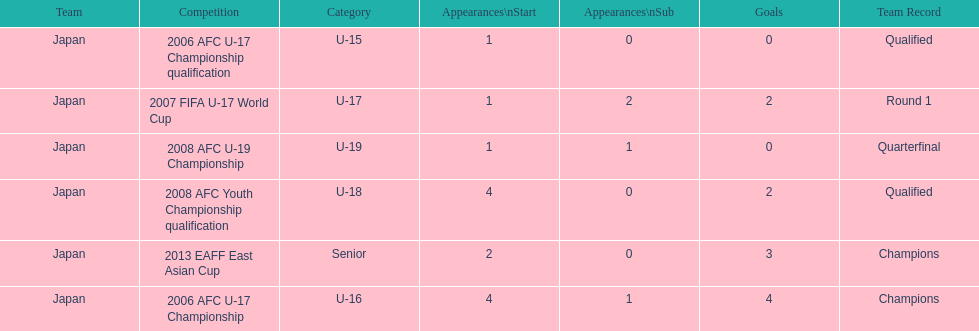In which two competitions did japan lack goals? 2006 AFC U-17 Championship qualification, 2008 AFC U-19 Championship. 